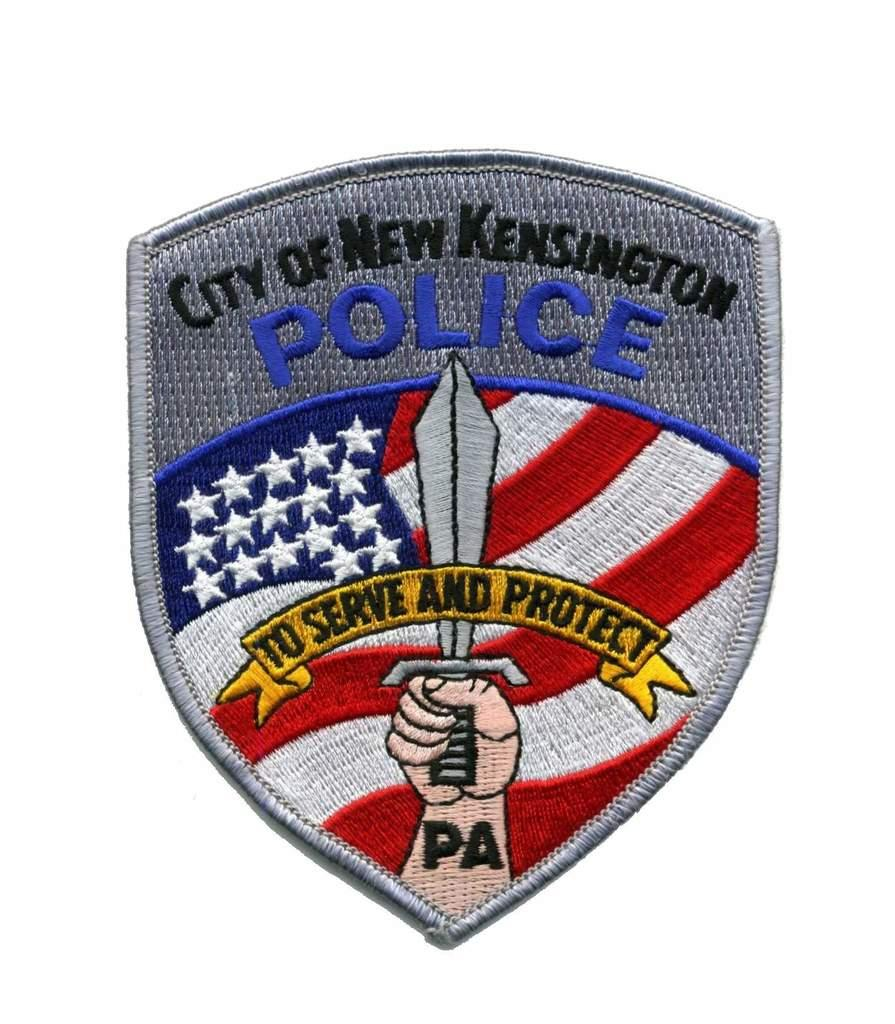What is the main subject of the image? The main subject of the image is a batch. What colors are present in the batch? The batch has colors: ash, blue, black, red, and white. What can be seen in the person's hand in the image? There is a person's hand holding a knife in the image. What is the color of the background in the image? The background of the image is white. Can you hear the grape being sliced by the knife in the image? There is no grape present in the image, and therefore it cannot be sliced or heard. 